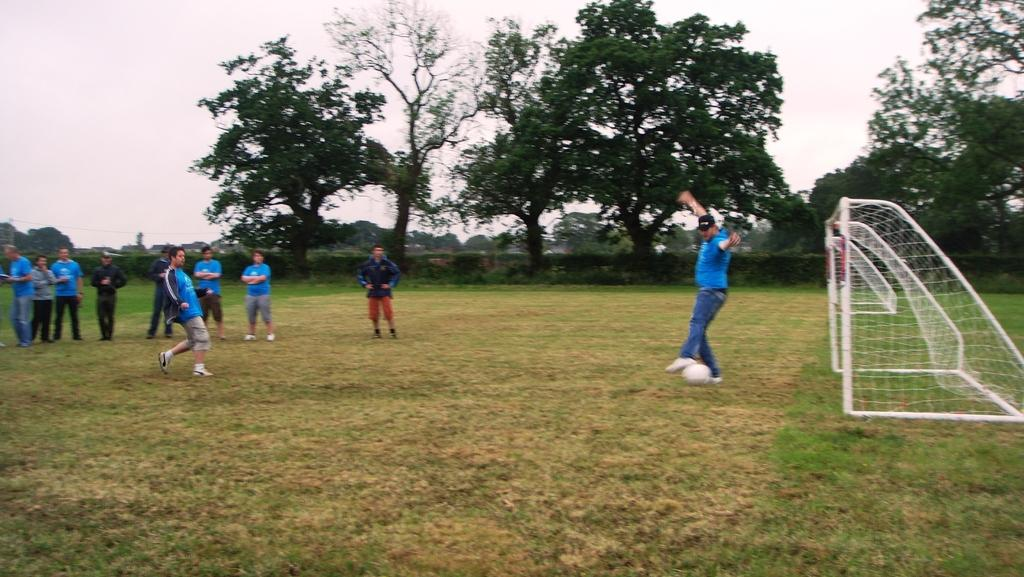What activity are the people in the image engaged in? The people in the image are playing football. Where is the football game taking place? The football game is taking place on a grassland. What can be seen in the background of the image? There are trees and the sky visible in the background of the image. What type of quince is being used as a football in the image? There is no quince present in the image; the people are playing with a regular football. Can you hear the drum being played in the background of the image? There is no drum present in the image, so it cannot be heard. 